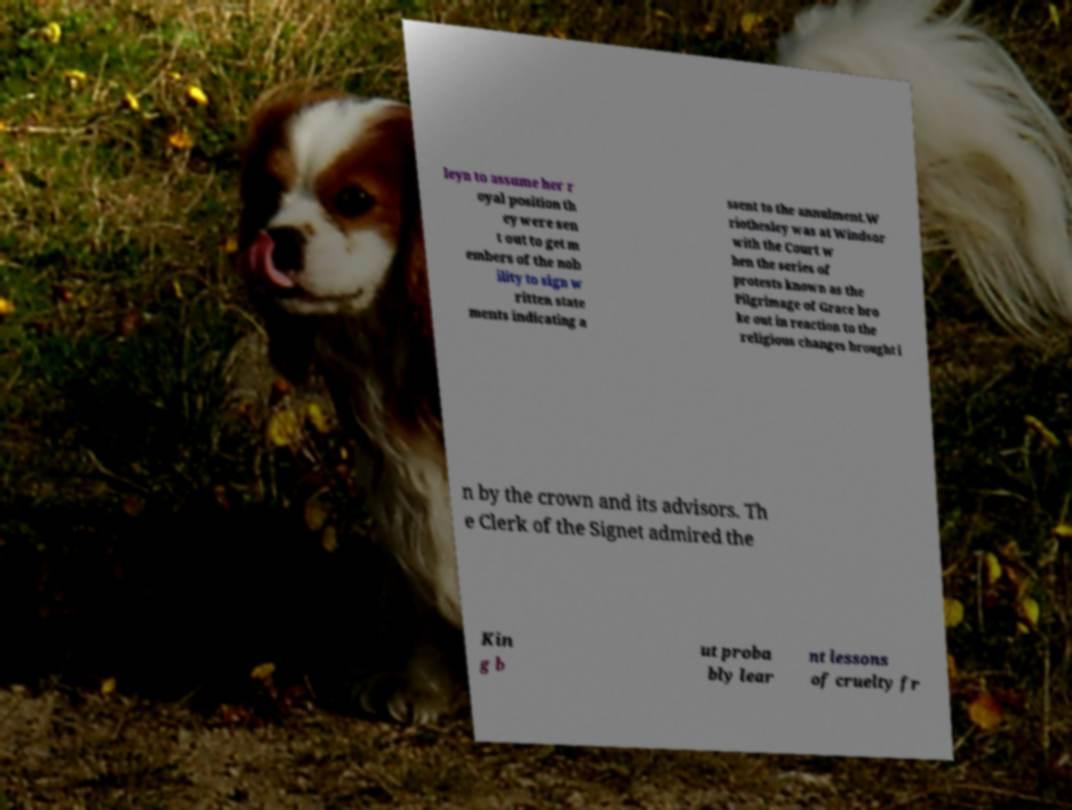Please read and relay the text visible in this image. What does it say? leyn to assume her r oyal position th ey were sen t out to get m embers of the nob ility to sign w ritten state ments indicating a ssent to the annulment.W riothesley was at Windsor with the Court w hen the series of protests known as the Pilgrimage of Grace bro ke out in reaction to the religious changes brought i n by the crown and its advisors. Th e Clerk of the Signet admired the Kin g b ut proba bly lear nt lessons of cruelty fr 